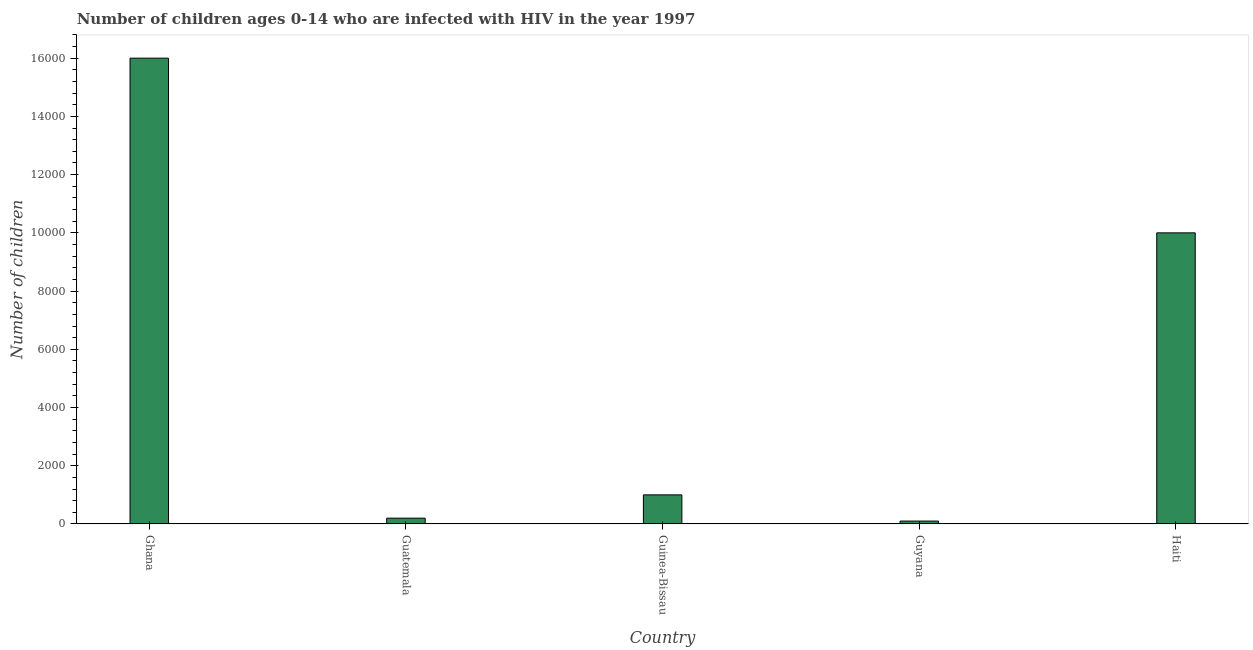Does the graph contain grids?
Give a very brief answer. No. What is the title of the graph?
Keep it short and to the point. Number of children ages 0-14 who are infected with HIV in the year 1997. What is the label or title of the Y-axis?
Provide a short and direct response. Number of children. What is the number of children living with hiv in Ghana?
Your response must be concise. 1.60e+04. Across all countries, what is the maximum number of children living with hiv?
Give a very brief answer. 1.60e+04. Across all countries, what is the minimum number of children living with hiv?
Make the answer very short. 100. In which country was the number of children living with hiv minimum?
Your answer should be very brief. Guyana. What is the sum of the number of children living with hiv?
Keep it short and to the point. 2.73e+04. What is the difference between the number of children living with hiv in Guyana and Haiti?
Your answer should be very brief. -9900. What is the average number of children living with hiv per country?
Make the answer very short. 5460. In how many countries, is the number of children living with hiv greater than 16400 ?
Provide a succinct answer. 0. Is the number of children living with hiv in Ghana less than that in Guyana?
Your answer should be very brief. No. What is the difference between the highest and the second highest number of children living with hiv?
Offer a terse response. 6000. Is the sum of the number of children living with hiv in Ghana and Guyana greater than the maximum number of children living with hiv across all countries?
Keep it short and to the point. Yes. What is the difference between the highest and the lowest number of children living with hiv?
Your answer should be very brief. 1.59e+04. In how many countries, is the number of children living with hiv greater than the average number of children living with hiv taken over all countries?
Keep it short and to the point. 2. Are all the bars in the graph horizontal?
Give a very brief answer. No. Are the values on the major ticks of Y-axis written in scientific E-notation?
Offer a very short reply. No. What is the Number of children of Ghana?
Ensure brevity in your answer.  1.60e+04. What is the Number of children of Guinea-Bissau?
Give a very brief answer. 1000. What is the Number of children of Haiti?
Provide a short and direct response. 10000. What is the difference between the Number of children in Ghana and Guatemala?
Make the answer very short. 1.58e+04. What is the difference between the Number of children in Ghana and Guinea-Bissau?
Your answer should be very brief. 1.50e+04. What is the difference between the Number of children in Ghana and Guyana?
Make the answer very short. 1.59e+04. What is the difference between the Number of children in Ghana and Haiti?
Your answer should be compact. 6000. What is the difference between the Number of children in Guatemala and Guinea-Bissau?
Your answer should be compact. -800. What is the difference between the Number of children in Guatemala and Haiti?
Provide a succinct answer. -9800. What is the difference between the Number of children in Guinea-Bissau and Guyana?
Offer a terse response. 900. What is the difference between the Number of children in Guinea-Bissau and Haiti?
Provide a succinct answer. -9000. What is the difference between the Number of children in Guyana and Haiti?
Offer a very short reply. -9900. What is the ratio of the Number of children in Ghana to that in Guinea-Bissau?
Offer a very short reply. 16. What is the ratio of the Number of children in Ghana to that in Guyana?
Keep it short and to the point. 160. What is the ratio of the Number of children in Guatemala to that in Guinea-Bissau?
Provide a succinct answer. 0.2. What is the ratio of the Number of children in Guatemala to that in Haiti?
Your response must be concise. 0.02. What is the ratio of the Number of children in Guinea-Bissau to that in Guyana?
Your response must be concise. 10. What is the ratio of the Number of children in Guyana to that in Haiti?
Make the answer very short. 0.01. 